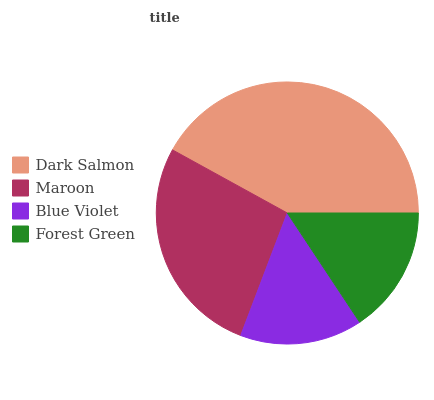Is Blue Violet the minimum?
Answer yes or no. Yes. Is Dark Salmon the maximum?
Answer yes or no. Yes. Is Maroon the minimum?
Answer yes or no. No. Is Maroon the maximum?
Answer yes or no. No. Is Dark Salmon greater than Maroon?
Answer yes or no. Yes. Is Maroon less than Dark Salmon?
Answer yes or no. Yes. Is Maroon greater than Dark Salmon?
Answer yes or no. No. Is Dark Salmon less than Maroon?
Answer yes or no. No. Is Maroon the high median?
Answer yes or no. Yes. Is Forest Green the low median?
Answer yes or no. Yes. Is Blue Violet the high median?
Answer yes or no. No. Is Maroon the low median?
Answer yes or no. No. 